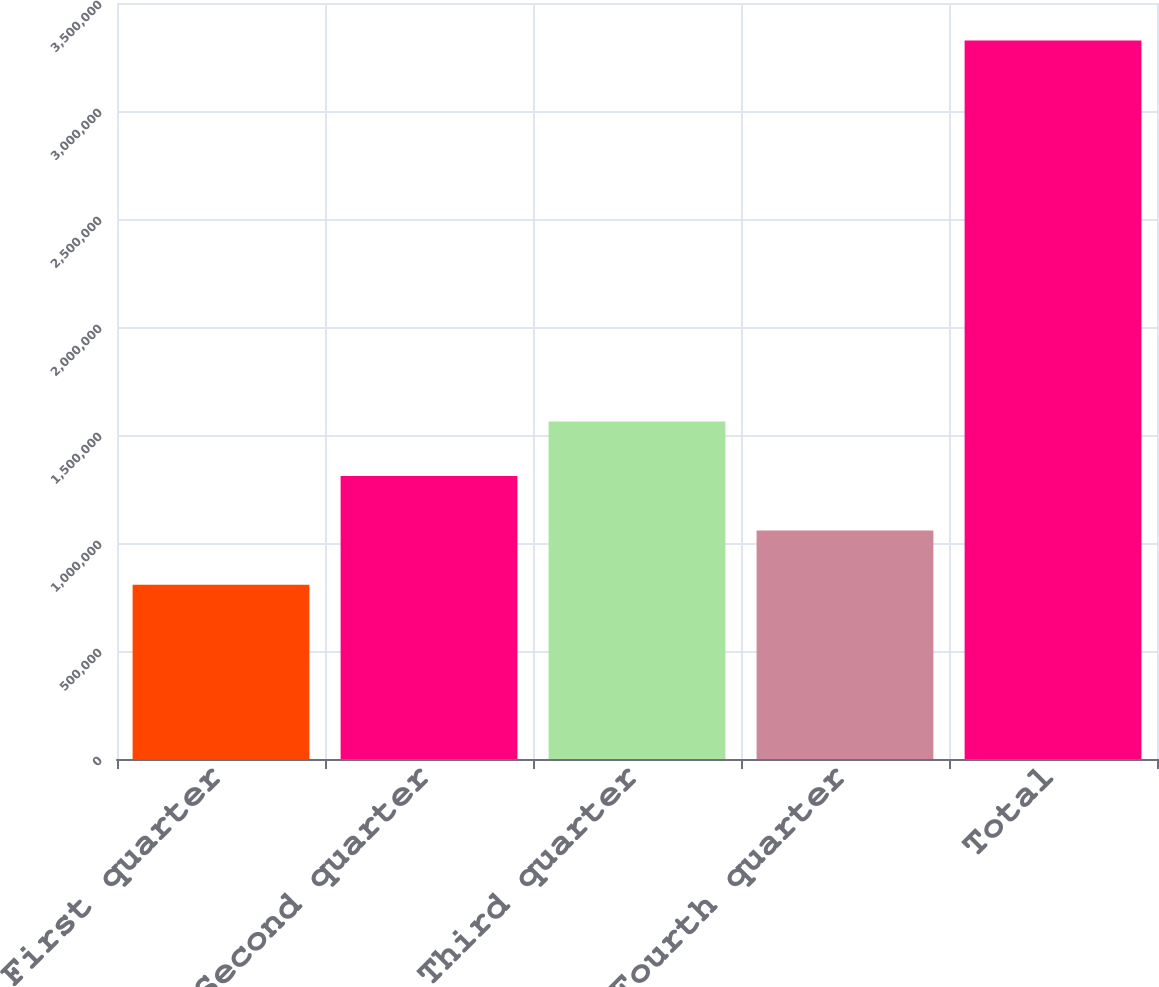Convert chart to OTSL. <chart><loc_0><loc_0><loc_500><loc_500><bar_chart><fcel>First quarter<fcel>Second quarter<fcel>Third quarter<fcel>Fourth quarter<fcel>Total<nl><fcel>806326<fcel>1.31028e+06<fcel>1.56226e+06<fcel>1.0583e+06<fcel>3.32611e+06<nl></chart> 